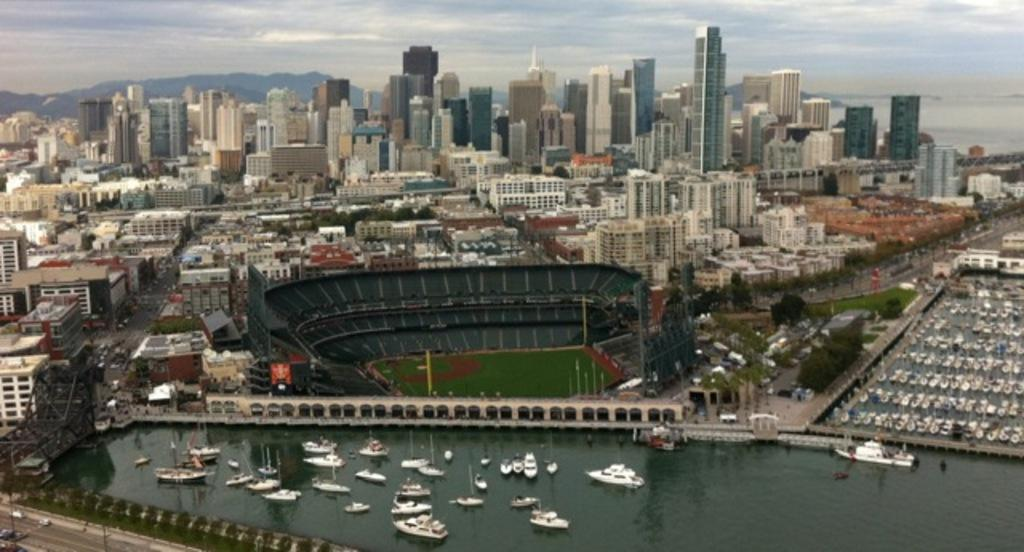What type of structures can be seen in the background of the image? There are big buildings in the background of the image. What is located in the middle of the image? There is a ground in the middle of the image. What natural element is visible in the image? There is water visible in the image. What is present in the water? There are ships in the water. What type of silk is being produced on the farm in the image? There is no farm or silk production present in the image. What angle is the image taken from? The angle from which the image is taken cannot be determined from the provided facts. 